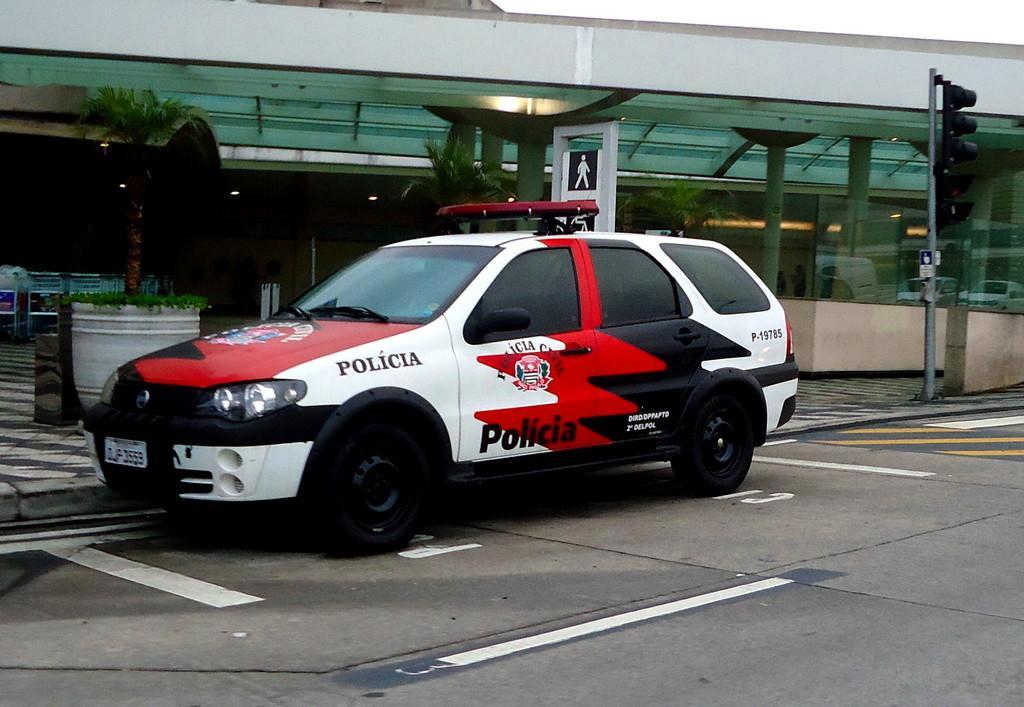Can you describe this image briefly? In this picture we can observe a car on the road. This car is in red, white and black in color. We can observe traffic signals fixed to the pole on the right side. In the background there are some trees and a building. 